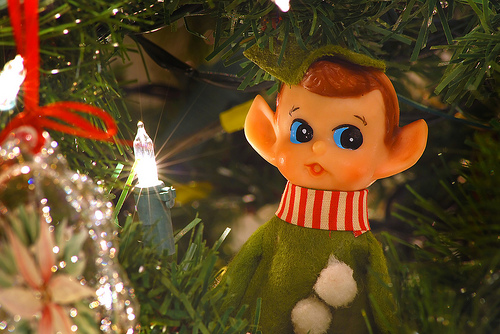<image>
Is there a elf in the tree? Yes. The elf is contained within or inside the tree, showing a containment relationship. 